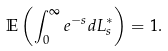Convert formula to latex. <formula><loc_0><loc_0><loc_500><loc_500>\mathbb { E } \left ( \int _ { 0 } ^ { \infty } e ^ { - s } d L _ { s } ^ { \ast } \right ) = 1 .</formula> 